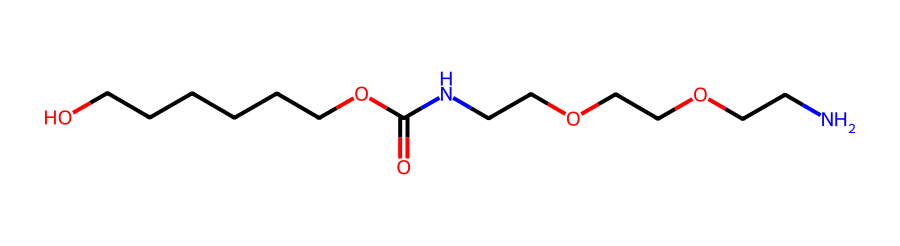What is the primary functional group present in this chemical? The chemical structure displays an amide group (-C(=O)N-), which is identifiable by the presence of the carbonyl (C=O) adjacent to a nitrogen atom (N). This group is a defining feature of polyurethanes.
Answer: amide How many carbon atoms are in the structure? By analyzing the SMILES representation, we can count the carbon (C) atoms throughout the entire chain and functional groups present. In total, there are 14 carbon atoms.
Answer: 14 What type of polymer is characterized by this chemical? The chemical contains both urethane and amide groups which primarily defines it as a polyurethane polymer—commonly used in padding and protective gear in sports.
Answer: polyurethane Which part of the chemical contributes to its flexibility? The polyether segments (indicated by the -O- repeating units between carbon chains) in the structure provide flexibility and elastic properties, which are crucial in applications such as football padding.
Answer: polyether segments What type of intermolecular forces are likely present due to the structure of this chemical? The presence of amide groups allows for hydrogen bonding between molecules, promoting stronger intermolecular forces. This characteristic contributes to the physical properties of the material, such as durability and resilience in football gear.
Answer: hydrogen bonding Which segment of the chemical aids in moisture resistance? The non-polar hydrocarbon chain (CCCCCC) contributes to hydrophobicity, assisting in moisture resistance, which is important for protective gear like shin guards.
Answer: hydrocarbon chain 